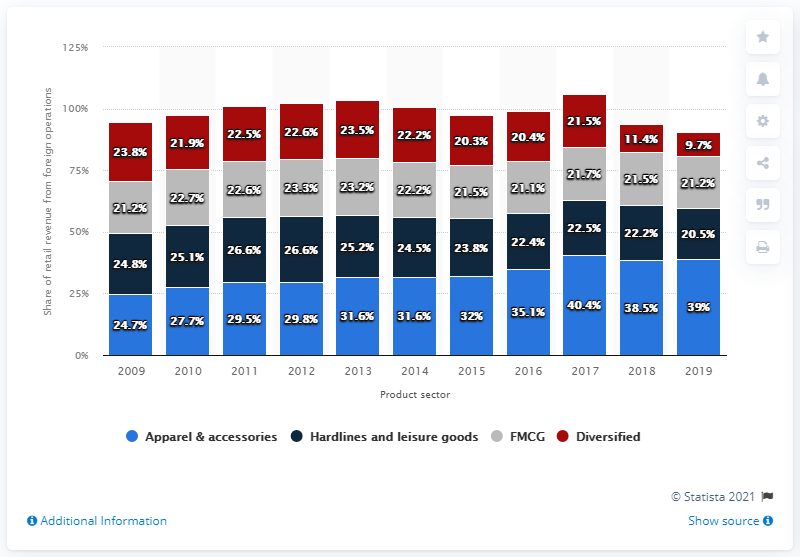Mention a couple of crucial points in this snapshot. The sum of FMCG data in 2018 and 2019 is 42.7. In 2018, the percentage for apparel and accessories was 38.5%. 